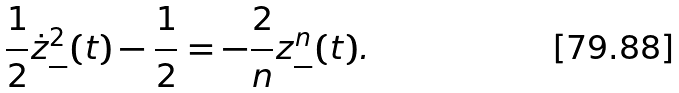Convert formula to latex. <formula><loc_0><loc_0><loc_500><loc_500>\frac { 1 } { 2 } \dot { z } _ { - } ^ { 2 } ( t ) - \frac { 1 } { 2 } = - \frac { 2 } { n } z _ { - } ^ { n } ( t ) .</formula> 